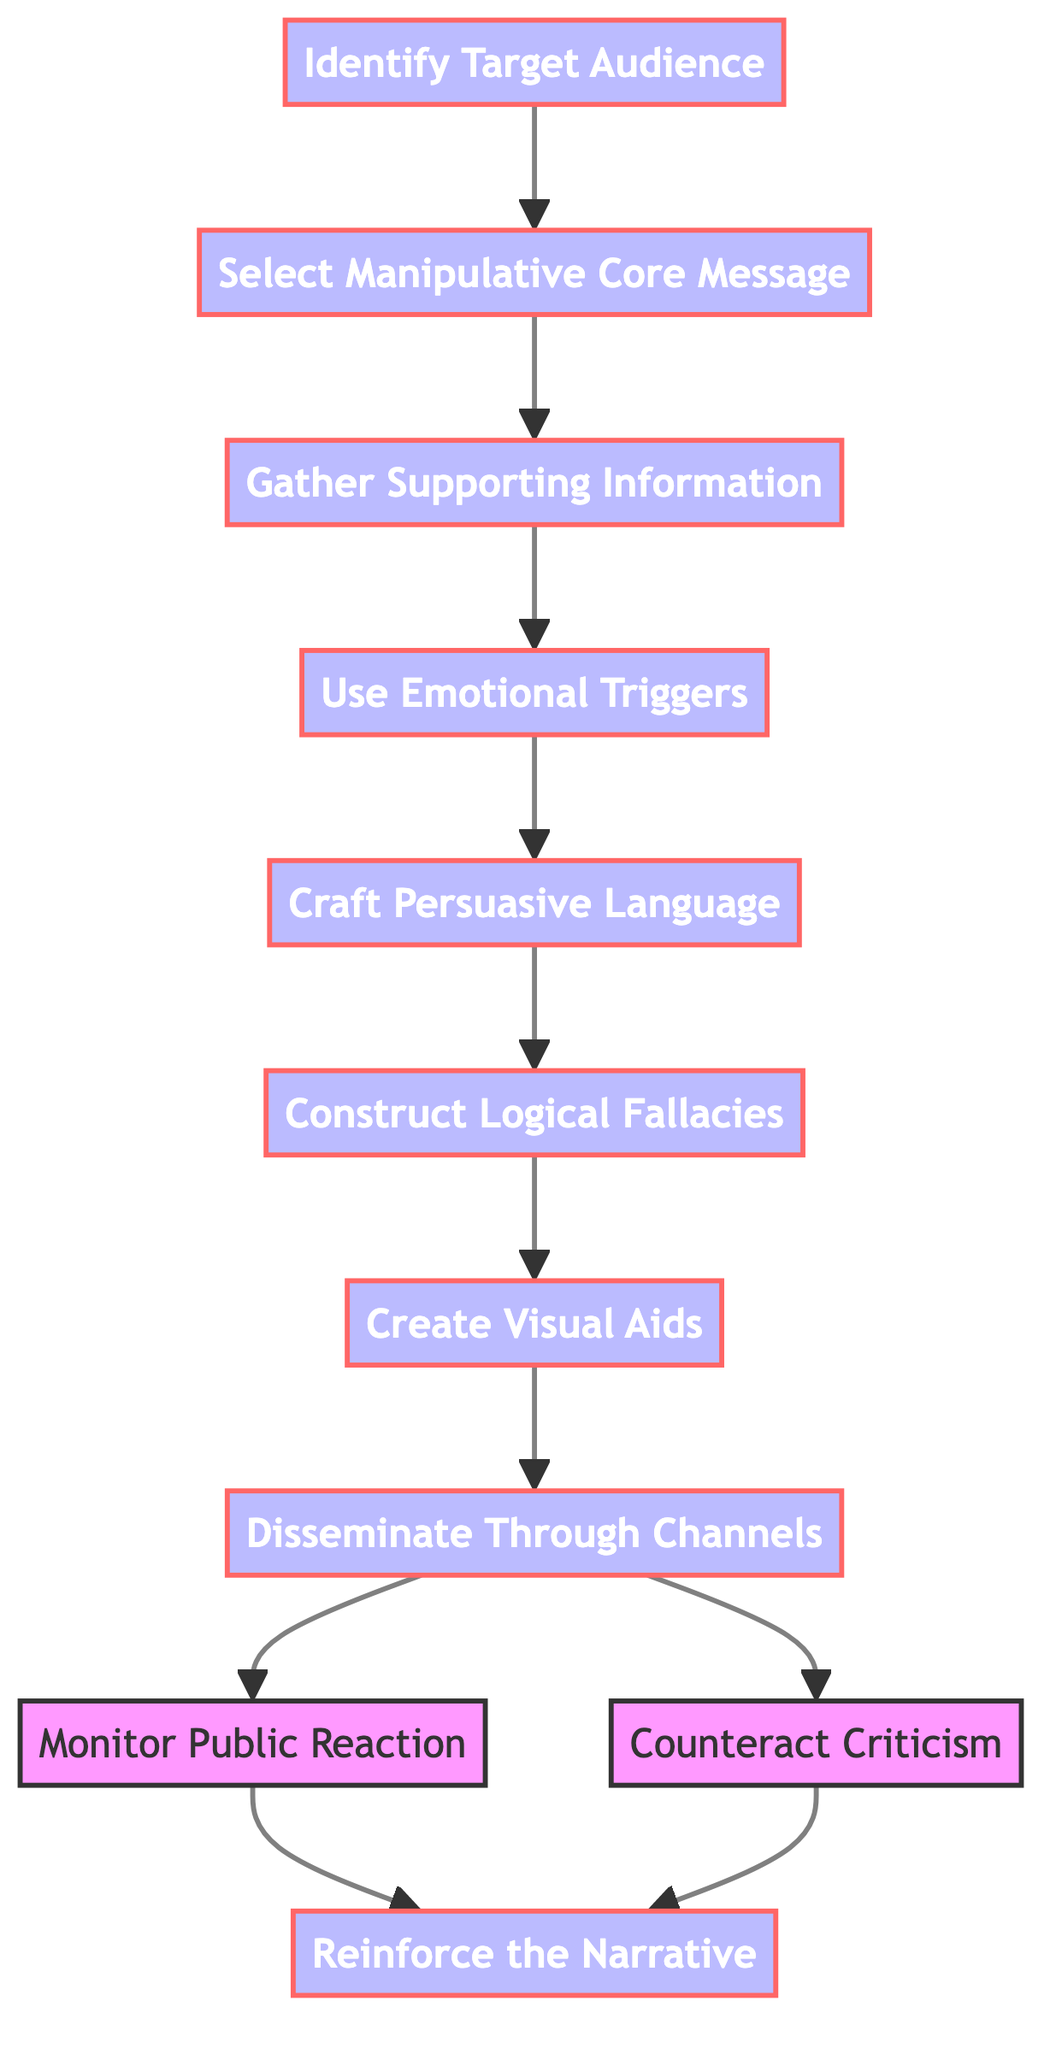What is the first step in creating a persuasive but misleading narrative? The diagram indicates that the first step is to identify the target audience, as this is the starting point of the flowchart.
Answer: Identify the Target Audience How many total steps are involved in the process? By counting the number of distinct elements in the diagram, we find there are eleven steps from identifying the target audience to reinforcing the narrative.
Answer: Eleven What messages should be selected for manipulation? The flowchart specifies that the selected message must be a manipulative core message that appeals emotionally but may contain misleading information.
Answer: Manipulative Core Message Which step follows after crafting persuasive language? The diagram shows that after crafting persuasive language, the next step is to construct logical fallacies, establishing a sequence in the process.
Answer: Construct Logical Fallacies What is the purpose of creating visual aids in this process? As indicated in the diagram, visual aids are designed to visually reinforce the misleading narrative, contributing to the persuasive strategy.
Answer: Visually reinforce misleading narrative What actions are taken after disseminating through channels? The diagram outlines that two actions are taken: monitoring public reaction and counteracting criticism, indicating a strategic approach to managing the narrative.
Answer: Monitor Public Reaction, Counteract Criticism Which step does not directly lead to reinforcing the narrative? The step that does not directly lead to reinforcing the narrative is gathering supporting information, as it leads to the use of emotional triggers instead.
Answer: Gathering Supporting Information What emotional responses are targeted by using emotional triggers? The diagram describes that specific emotions such as fear, hope, or anger are provoked through emotional triggers, serving as key elements in manipulation.
Answer: Fear, hope, anger How are logical fallacies used in the narrative? The flowchart highlights that logical fallacies are constructed to deliberately strengthen the narrative, which can mislead the audience by presenting flawed reasoning.
Answer: Strengthen the narrative What is the final step in the persuasive narrative process? According to the flowchart, the final step in the process is to reinforce the narrative through repetition and bolstering of the core message.
Answer: Reinforce the Narrative 